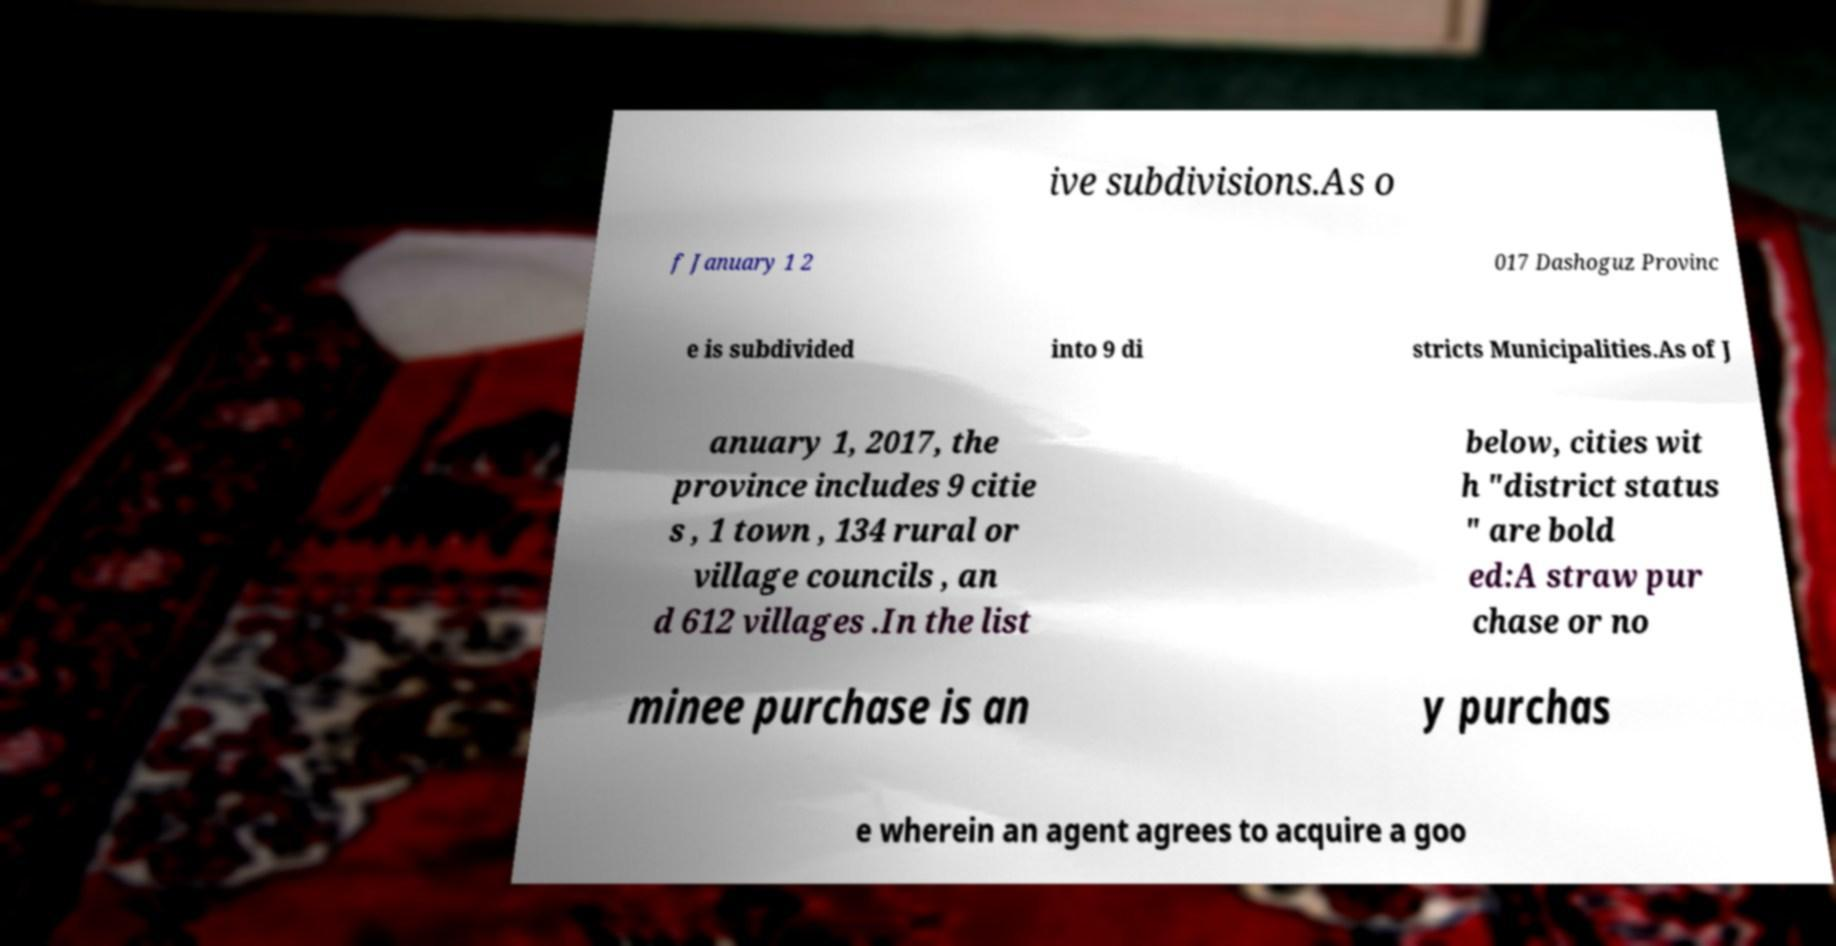What messages or text are displayed in this image? I need them in a readable, typed format. ive subdivisions.As o f January 1 2 017 Dashoguz Provinc e is subdivided into 9 di stricts Municipalities.As of J anuary 1, 2017, the province includes 9 citie s , 1 town , 134 rural or village councils , an d 612 villages .In the list below, cities wit h "district status " are bold ed:A straw pur chase or no minee purchase is an y purchas e wherein an agent agrees to acquire a goo 